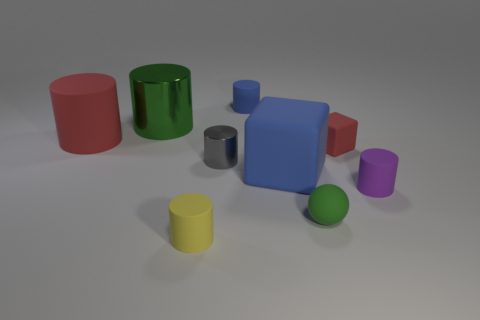Subtract all purple cylinders. How many cylinders are left? 5 Subtract all gray shiny cylinders. How many cylinders are left? 5 Subtract all yellow cylinders. Subtract all gray blocks. How many cylinders are left? 5 Add 1 small green spheres. How many objects exist? 10 Subtract all spheres. How many objects are left? 8 Add 8 metal cylinders. How many metal cylinders are left? 10 Add 2 yellow matte things. How many yellow matte things exist? 3 Subtract 0 yellow balls. How many objects are left? 9 Subtract all red rubber things. Subtract all large blue cubes. How many objects are left? 6 